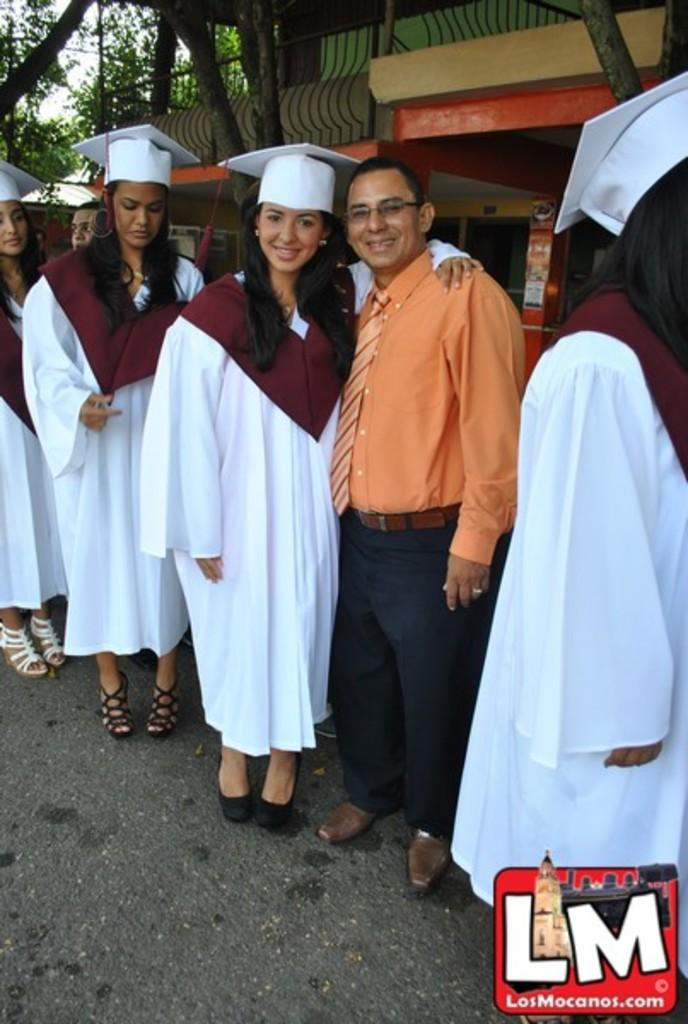What are the people in the image doing? The people in the image are standing and smiling. What can be seen in the background of the image? There is a building and trees in the background of the image. What type of art is being created in the image? There is no art being created in the image; it simply shows people standing and smiling with a background of a building and trees. 